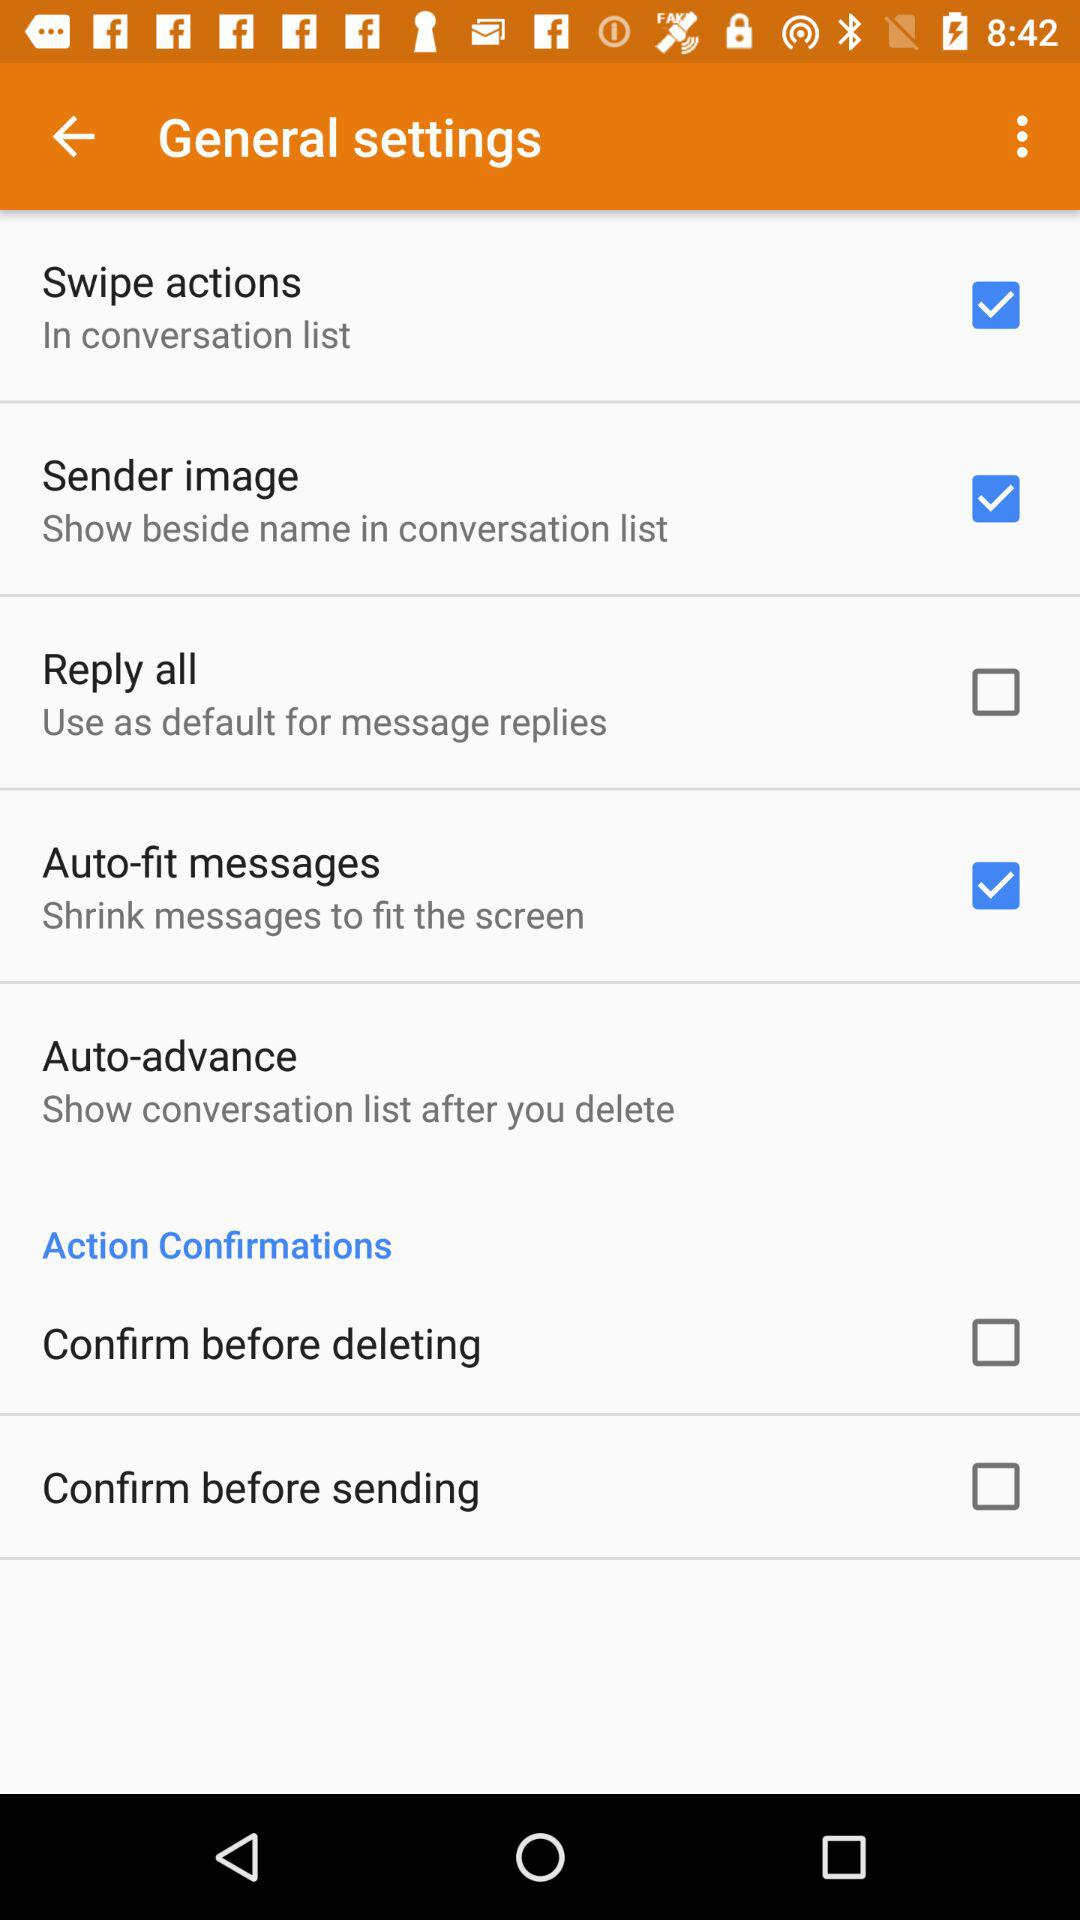What are the checked general settings? The checked general settings are "Swipe actions", "Sender image" and "Auto-fit messages". 